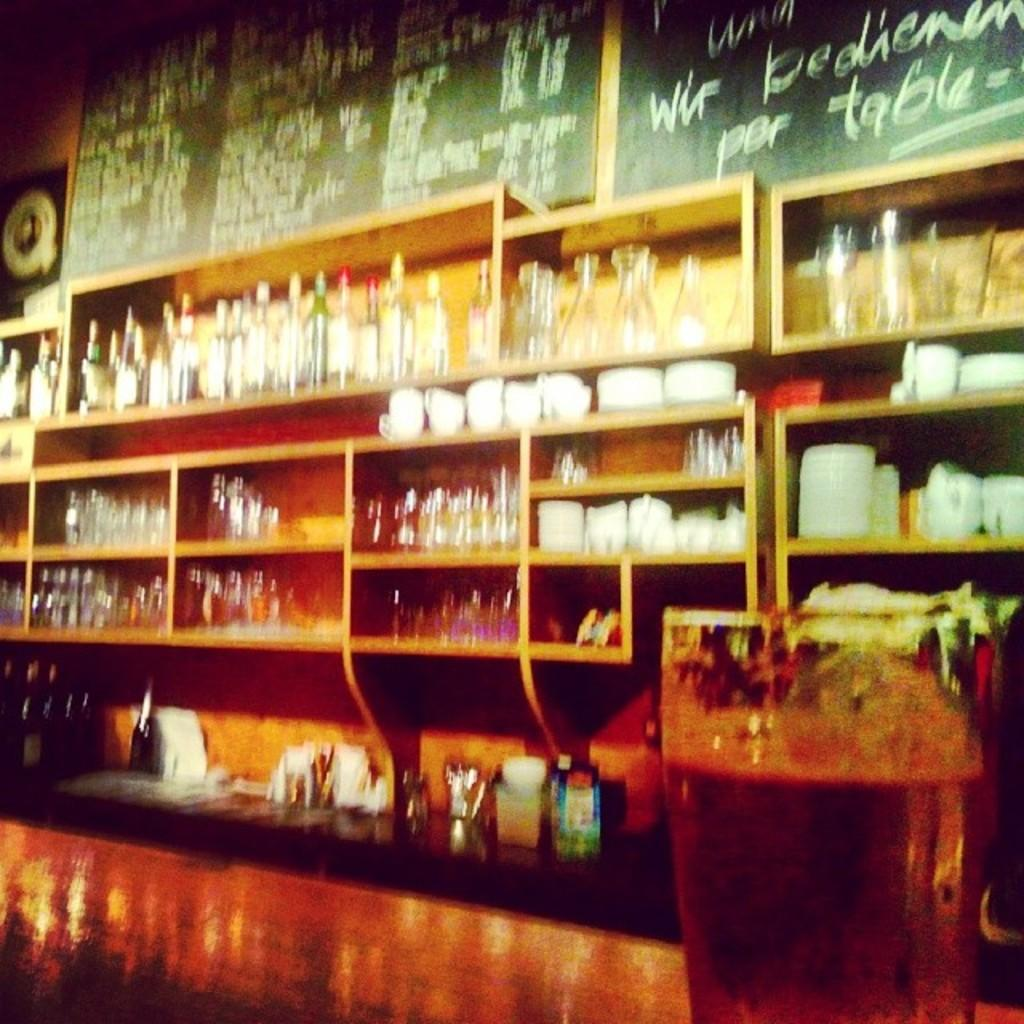<image>
Render a clear and concise summary of the photo. A bar with lots of bottles on shelves with a chalkboard that says por table. 